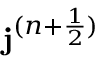Convert formula to latex. <formula><loc_0><loc_0><loc_500><loc_500>j ^ { ( n + \frac { 1 } { 2 } ) }</formula> 